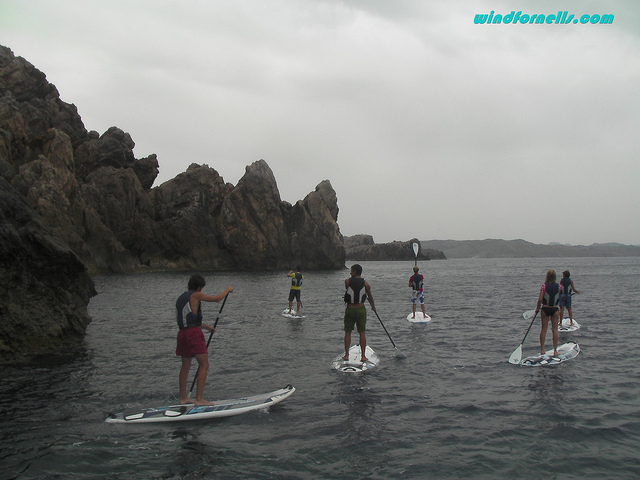Please identify all text content in this image. windfornells.com 